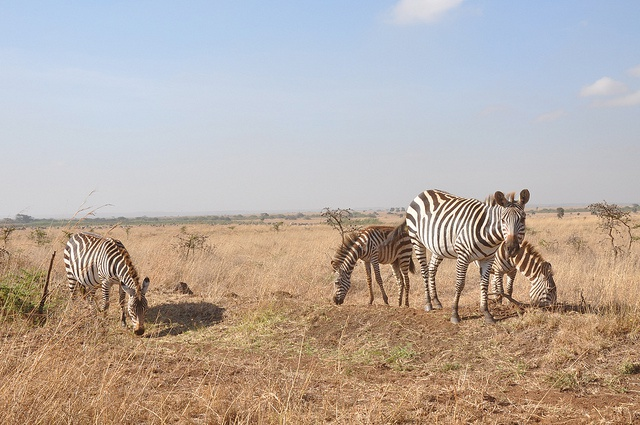Describe the objects in this image and their specific colors. I can see zebra in lightblue, ivory, gray, and maroon tones, zebra in lightblue, gray, tan, ivory, and maroon tones, zebra in lightblue, maroon, and gray tones, and zebra in lightblue, maroon, gray, and tan tones in this image. 